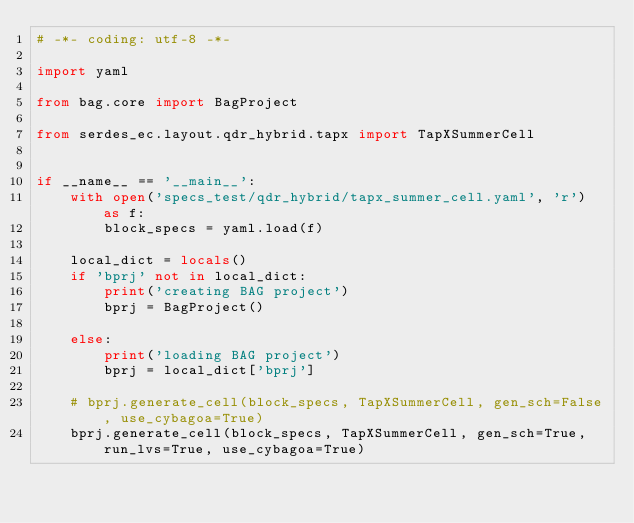Convert code to text. <code><loc_0><loc_0><loc_500><loc_500><_Python_># -*- coding: utf-8 -*-

import yaml

from bag.core import BagProject

from serdes_ec.layout.qdr_hybrid.tapx import TapXSummerCell


if __name__ == '__main__':
    with open('specs_test/qdr_hybrid/tapx_summer_cell.yaml', 'r') as f:
        block_specs = yaml.load(f)

    local_dict = locals()
    if 'bprj' not in local_dict:
        print('creating BAG project')
        bprj = BagProject()

    else:
        print('loading BAG project')
        bprj = local_dict['bprj']

    # bprj.generate_cell(block_specs, TapXSummerCell, gen_sch=False, use_cybagoa=True)
    bprj.generate_cell(block_specs, TapXSummerCell, gen_sch=True, run_lvs=True, use_cybagoa=True)
</code> 